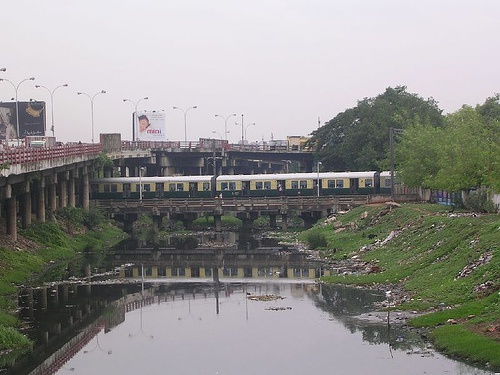Describe the objects in this image and their specific colors. I can see train in lightgray, gray, black, and darkgray tones, people in lightgray, pink, darkgray, and gray tones, and people in lightgray, darkgray, gray, and black tones in this image. 